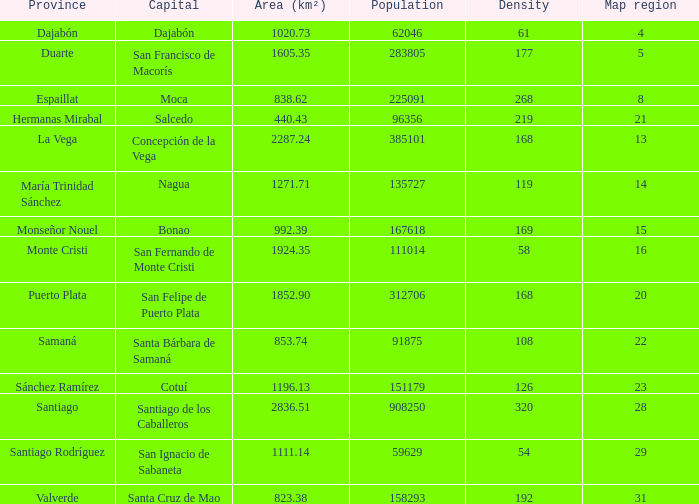Nagua has the area (km²) of? 1271.71. 